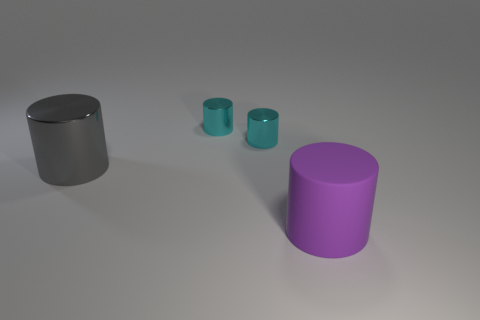Subtract all large shiny cylinders. How many cylinders are left? 3 Add 4 cyan things. How many objects exist? 8 Subtract all yellow cylinders. Subtract all cyan spheres. How many cylinders are left? 4 Add 4 purple cylinders. How many purple cylinders are left? 5 Add 3 yellow spheres. How many yellow spheres exist? 3 Subtract 0 yellow balls. How many objects are left? 4 Subtract all tiny purple metal balls. Subtract all tiny things. How many objects are left? 2 